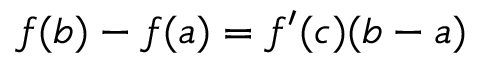Convert formula to latex. <formula><loc_0><loc_0><loc_500><loc_500>f ( b ) - f ( a ) = f ^ { \prime } ( c ) ( b - a )</formula> 